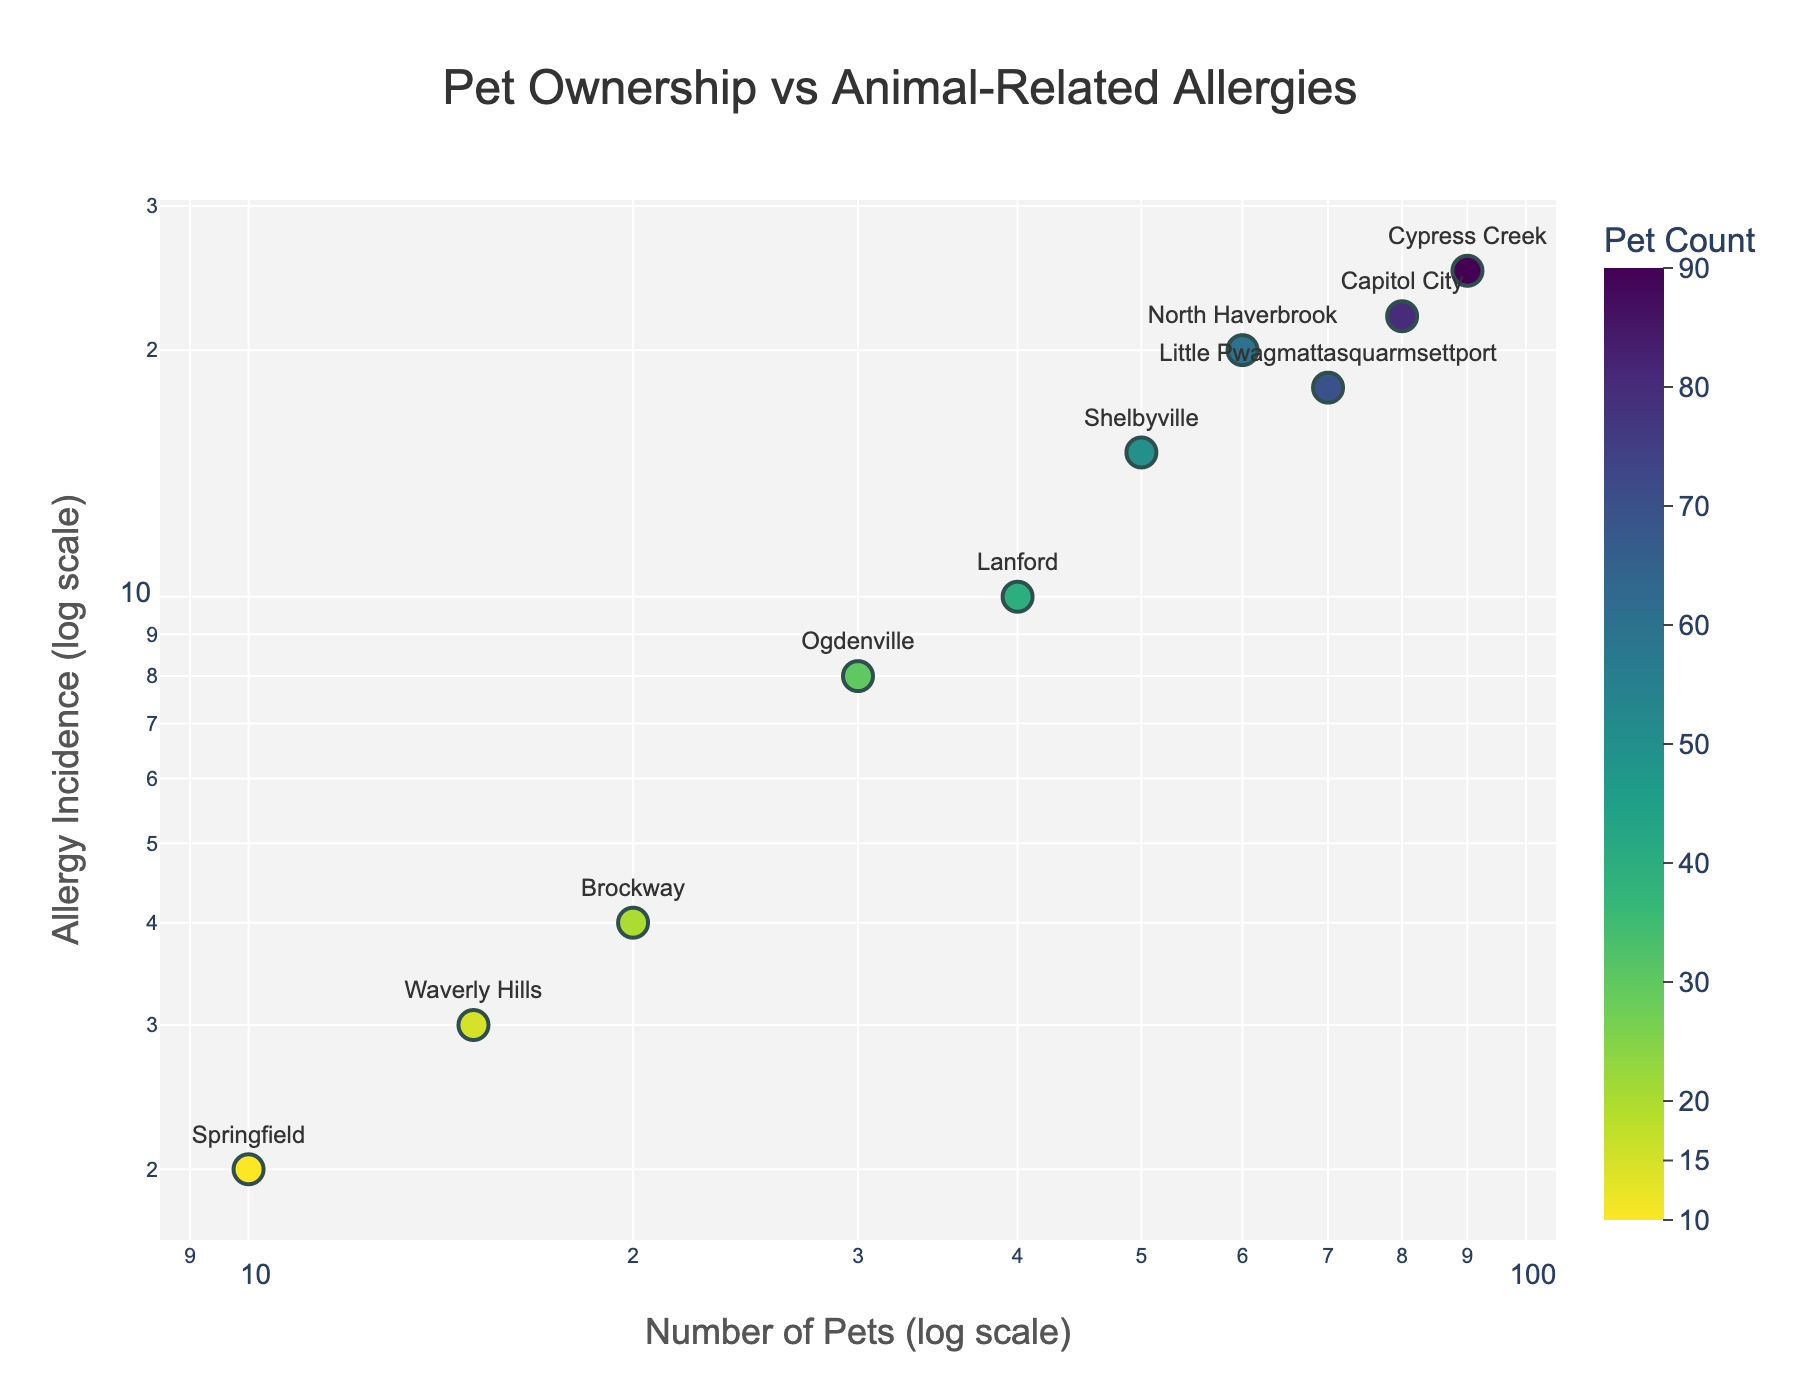What is the title of the plot? The title of the plot is located at the top center and is usually the most prominent text element.
Answer: Pet Ownership vs Animal-Related Allergies Which axes are using logarithmic scales? Identify the axis labels. Both the x-axis and y-axis labels include the term "log scale", indicating they are logarithmic scales.
Answer: Both axes What are the variables plotted on the x-axis and y-axis? Refer to the axis labels. They indicate that the x-axis represents the Number of Pets and the y-axis represents Allergy Incidence.
Answer: Number of Pets (log scale) and Allergy Incidence (log scale) How many data points are displayed? Count the number of markers on the scatter plot. Each marker represents a data point.
Answer: 10 Which location has the highest incidence of animal-related allergies? Look for the data point with the highest value on the y-axis and identify the associated location.
Answer: Cypress Creek Which location has the lowest number of pets? Look for the data point with the lowest value on the x-axis and identify the associated location.
Answer: Springfield Is there any location that falls exactly on the diagonal, indicating a proportional relationship between pet ownership and allergy incidence? Check if any data points lie exactly on the diagonal line, where y=x (assuming the same log scale for both axes).
Answer: No What is the range of the number of pets in the data? Identify the minimum and maximum values on the x-axis. The minimum is near 10 and the maximum near 90.
Answer: 10 to 90 pets Compare the allergy incidence in Capitol City and North Haverbrook. Which one has a higher incidence? Locate the data points for Capitol City and North Haverbrook and compare their positions on the y-axis.
Answer: North Haverbrook What is the average allergy incidence for locations with more than 50 pets? Identify locations with more than 50 pets and calculate the average of their allergy incidence. The locations are North Haverbrook, Cypress Creek, Capitol City, Little Pwagmattasquarmsettport, and Shelbyville. Their incidences are 20, 25, 22, 18, and 15 respectively. The average is (20+25+22+18+15)/5.
Answer: 20 